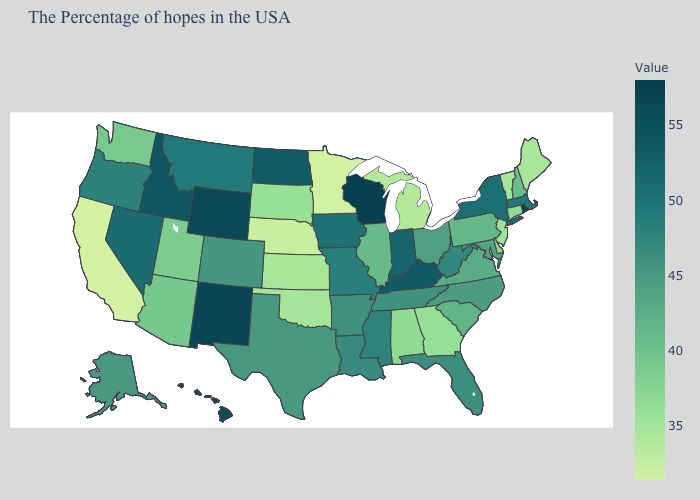Does Arkansas have the highest value in the South?
Write a very short answer. No. Which states hav the highest value in the South?
Give a very brief answer. Kentucky. Among the states that border Kansas , which have the highest value?
Concise answer only. Missouri. Does Montana have the lowest value in the West?
Short answer required. No. Among the states that border New York , does Vermont have the lowest value?
Be succinct. Yes. 